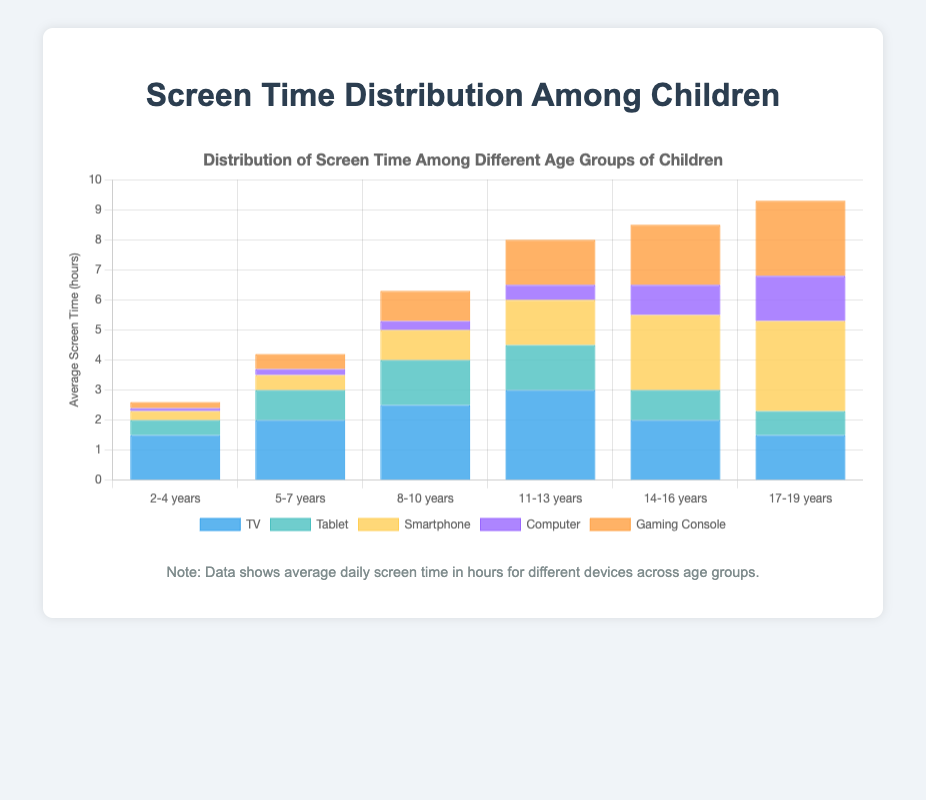What's the total screen time for children aged 2-4 years? To find the total screen time for children aged 2-4 years, sum up all the screen time values for each device: TV (1.5) + Tablet (0.5) + Smartphone (0.3) + Computer (0.1) + Gaming Console (0.2) = 2.6 hours.
Answer: 2.6 hours Which age group spends the most time on smartphones? By comparing the average smartphone screen time across all age groups, the 17-19 years group has the highest value of 3.0 hours.
Answer: 17-19 years How does TV screen time change from age 2-4 to 14-16? The TV screen time for the 2-4 years group is 1.5 hours, and for the 14-16 years group, it is 2.0 hours. The change (increase) is calculated by 2.0 - 1.5 = 0.5 hours.
Answer: Increases by 0.5 hours Which device shows the most consistent usage across all age groups? By visually assessing the heights of the bars for each device across the different age groups, the Computer shows the most consistent usage with values ranging fairly narrowly from 0.1 to 1.5 hours.
Answer: Computer What is the combined screen time for TV and Gaming Console for children aged 11-13 years? For children aged 11-13 years, the TV screen time is 3.0 hours and the Gaming Console screen time is 1.5 hours. Adding these together: 3.0 + 1.5 = 4.5 hours.
Answer: 4.5 hours Which age group shows the highest total screen time? Calculate the total screen time for each age group by adding up the hours for all devices. The 17-19 years age group has the highest total: TV (1.5) + Tablet (0.8) + Smartphone (3.0) + Computer (1.5) + Gaming Console (2.5) = 9.3 hours.
Answer: 17-19 years By how much does smartphone screen time increase from age group 5-7 years to 14-16 years? The smartphone screen time for the 5-7 years group is 0.5 hours, and for the 14-16 years group, it is 2.5 hours. The increase is calculated as 2.5 - 0.5 = 2.0 hours.
Answer: 2.0 hours Which device has the least average screen time for the 2-4 years age group? By comparing the screen time values for each device in the 2-4 years age group, the Computer has the least average screen time of 0.1 hours.
Answer: Computer What is the difference in total screen time between the 8-10 and 11-13 age groups? Calculate the total screen time for each group and find the difference. For 8-10 years: TV (2.5) + Tablet (1.5) + Smartphone (1.0) + Computer (0.3) + Gaming Console (1.0) = 6.3 hours. For 11-13 years: TV (3.0) + Tablet (1.5) + Smartphone (1.5) + Computer (0.5) + Gaming Console (1.5) = 8.0 hours. The difference is 8.0 - 6.3 = 1.7 hours.
Answer: 1.7 hours What is the average gaming console screen time across all age groups? Sum the Gaming Console screen times across all age groups and divide by the number of age groups. (0.2 + 0.5 + 1.0 + 1.5 + 2.0 + 2.5) / 6 = 7.7 / 6 ≈ 1.28 hours.
Answer: 1.28 hours 